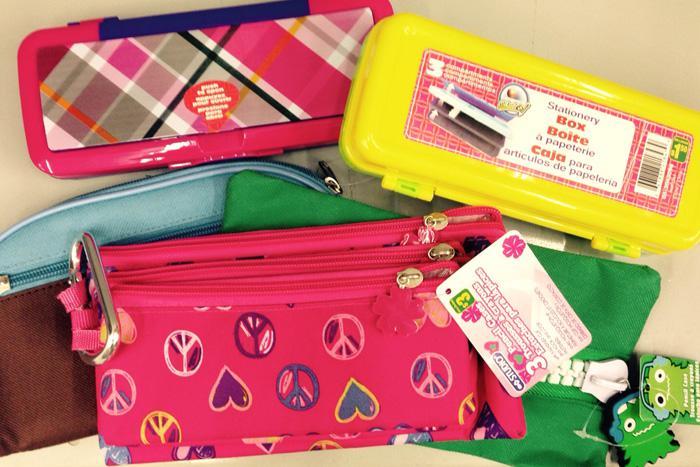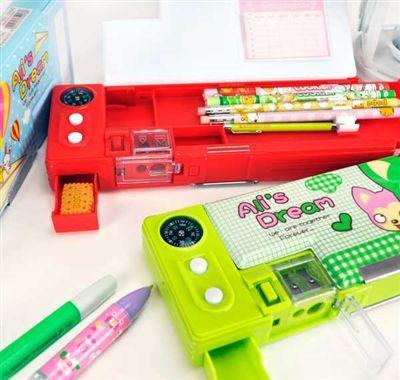The first image is the image on the left, the second image is the image on the right. Analyze the images presented: Is the assertion "The right image shows hard plastic-look cases in bright colors." valid? Answer yes or no. Yes. 